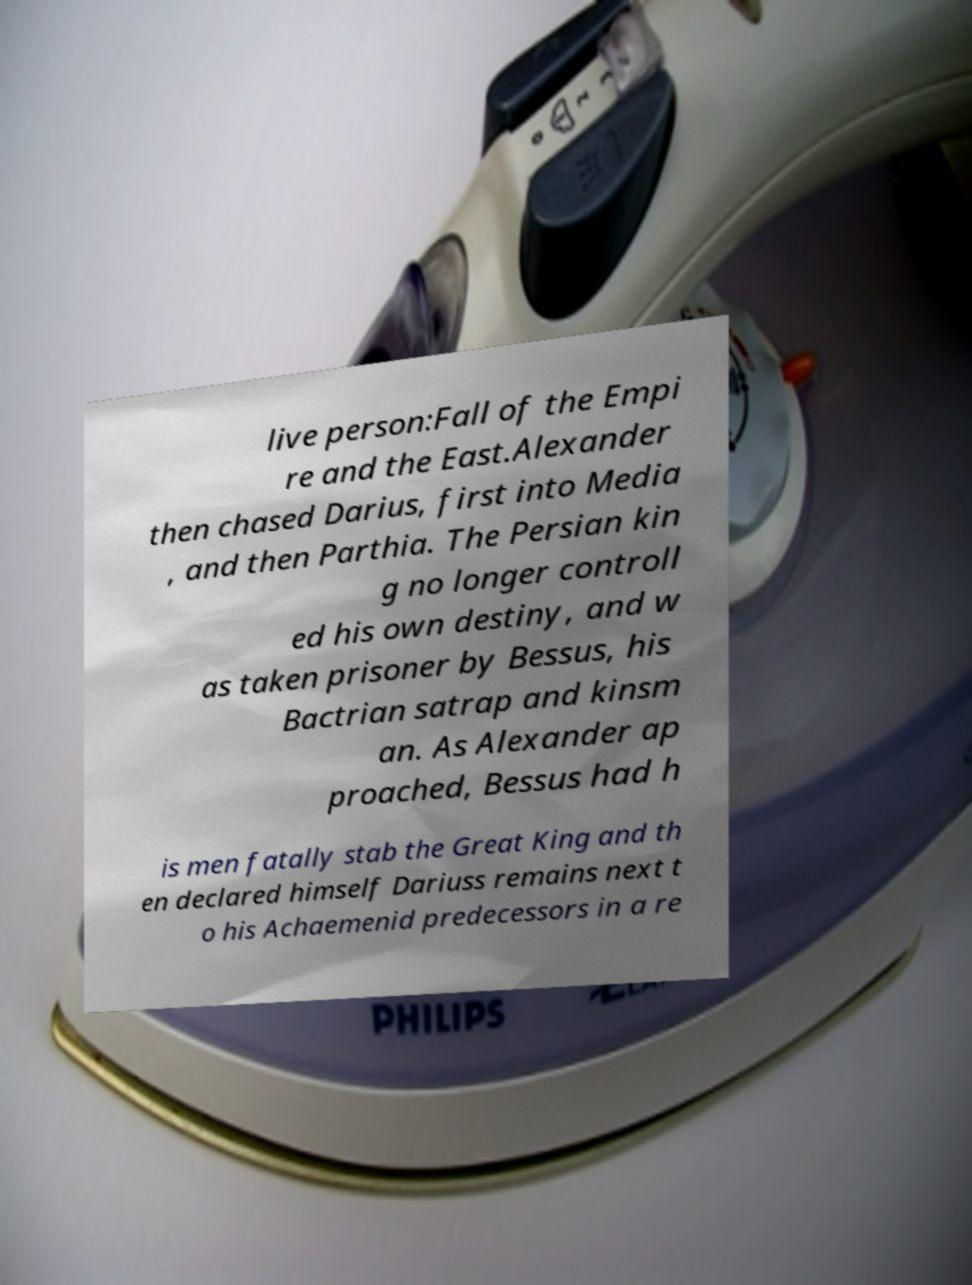Can you read and provide the text displayed in the image?This photo seems to have some interesting text. Can you extract and type it out for me? live person:Fall of the Empi re and the East.Alexander then chased Darius, first into Media , and then Parthia. The Persian kin g no longer controll ed his own destiny, and w as taken prisoner by Bessus, his Bactrian satrap and kinsm an. As Alexander ap proached, Bessus had h is men fatally stab the Great King and th en declared himself Dariuss remains next t o his Achaemenid predecessors in a re 